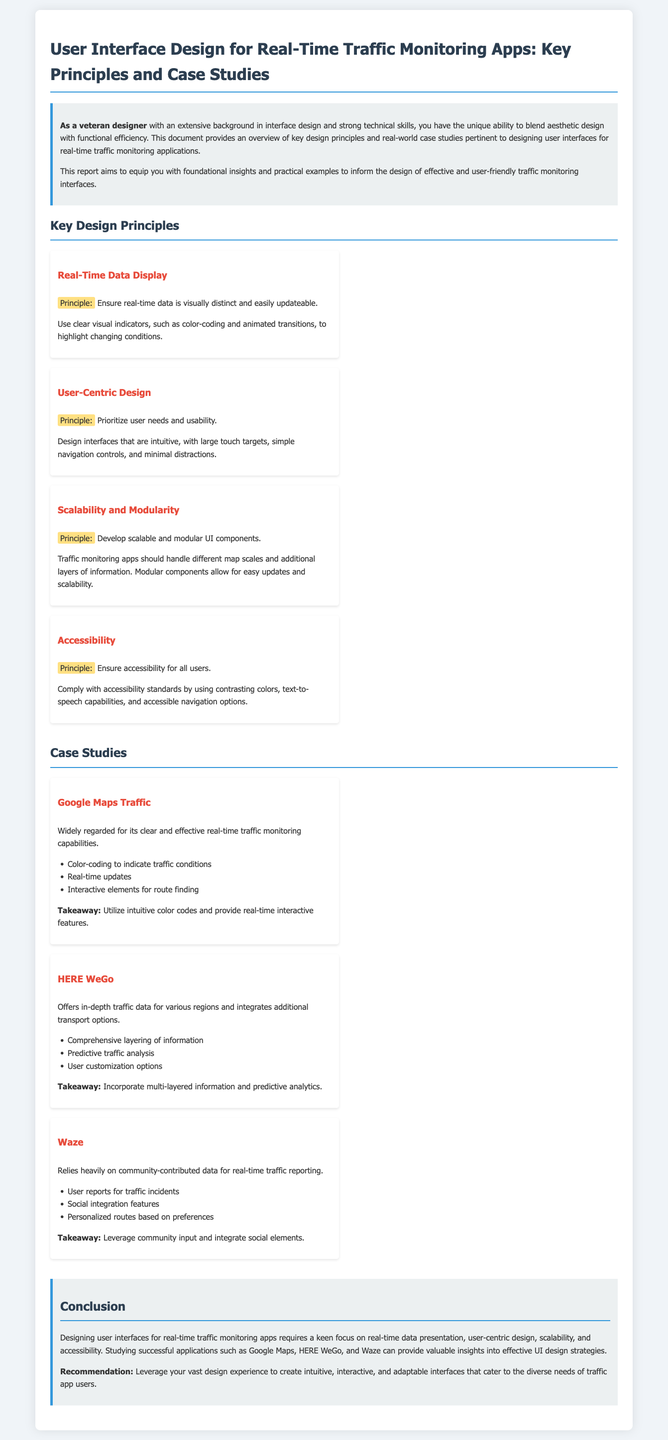What is the title of the document? The title of the document is prominently displayed in the header section, focusing on UI design for traffic monitoring apps.
Answer: User Interface Design for Real-Time Traffic Monitoring Apps: Key Principles and Case Studies What principle ensures accessibility? The principle ensures accessibility for all users is explicitly mentioned and highlighted within the key design principles section.
Answer: Accessibility How many case studies are presented? The number of case studies can be counted in the case studies section of the document.
Answer: Three What design principle focuses on user needs? The design principle that emphasizes understanding and prioritizing user needs is stated clearly in the key principles section.
Answer: User-Centric Design Which case study emphasizes community-contributed data? The case study that is focused on community engagement regarding traffic reporting is mentioned in the case studies section.
Answer: Waze What is a key takeaway from the HERE WeGo case study? The takeaway from the HERE WeGo case study can be found at the end of its description, summarizing the primary lesson.
Answer: Incorporate multi-layered information and predictive analytics What is highlighted as important in real-time data display? The visualization aspect of real-time data is discussed under the key design principles, indicating what should be visually distinct.
Answer: Clear visual indicators Which application is noted for real-time updates? The application noted for its effective real-time traffic monitoring capabilities can be identified under its case study.
Answer: Google Maps 